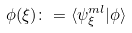Convert formula to latex. <formula><loc_0><loc_0><loc_500><loc_500>\phi ( { \xi } ) \colon = \langle \psi _ { \xi } ^ { m l } | \phi \rangle</formula> 